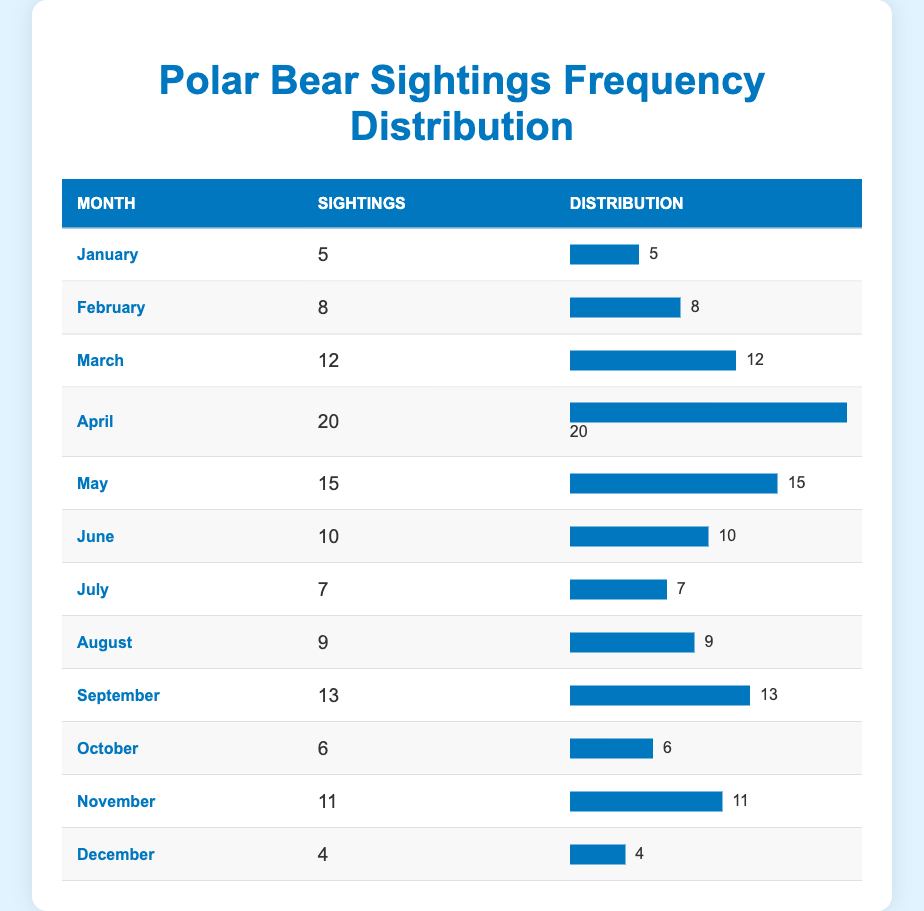What is the month with the highest number of polar bear sightings? Looking through the table, we identify that April has the highest number of sightings at 20.
Answer: April How many sightings were recorded in January? January has 5 sightings as shown in the table.
Answer: 5 What is the average number of polar bear sightings per month? To calculate the average, we sum the total sightings: 5 + 8 + 12 + 20 + 15 + 10 + 7 + 9 + 13 + 6 + 11 + 4 =  130. There are 12 months, hence the average is 130/12 = 10.83.
Answer: 10.83 Did more sightings occur in December compared to February? December had 4 sightings while February had 8 sightings. Since 4 is less than 8, February had more sightings than December.
Answer: No What is the total number of sightings recorded from April to August? We add the sightings from April (20), May (15), June (10), July (7), and August (9) together: 20 + 15 + 10 + 7 + 9 = 71.
Answer: 71 How many months had sightings fewer than 10? The months with fewer than 10 sightings are January (5), July (7), October (6), and December (4). That totals to 4 months.
Answer: 4 What is the difference in the number of sightings between the month with the highest and lowest sightings? April (highest) has 20 sightings and December (lowest) has 4 sightings. The difference is 20 - 4 = 16.
Answer: 16 Which month has the second-highest number of sightings? After April, the next highest is May which has 15 sightings, ranking it as the second.
Answer: May Is the number of sightings in March greater than the average? March has 12 sightings. We previously calculated the average to be 10.83, so 12 is indeed greater than 10.83.
Answer: Yes 